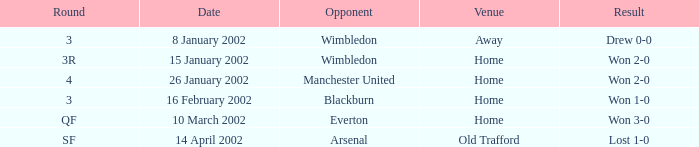What is the Venue with a Date with 14 april 2002? Old Trafford. Would you be able to parse every entry in this table? {'header': ['Round', 'Date', 'Opponent', 'Venue', 'Result'], 'rows': [['3', '8 January 2002', 'Wimbledon', 'Away', 'Drew 0-0'], ['3R', '15 January 2002', 'Wimbledon', 'Home', 'Won 2-0'], ['4', '26 January 2002', 'Manchester United', 'Home', 'Won 2-0'], ['3', '16 February 2002', 'Blackburn', 'Home', 'Won 1-0'], ['QF', '10 March 2002', 'Everton', 'Home', 'Won 3-0'], ['SF', '14 April 2002', 'Arsenal', 'Old Trafford', 'Lost 1-0']]} 